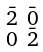<formula> <loc_0><loc_0><loc_500><loc_500>\begin{smallmatrix} \bar { 2 } & \bar { 0 } \\ 0 & \bar { 2 } \end{smallmatrix}</formula> 